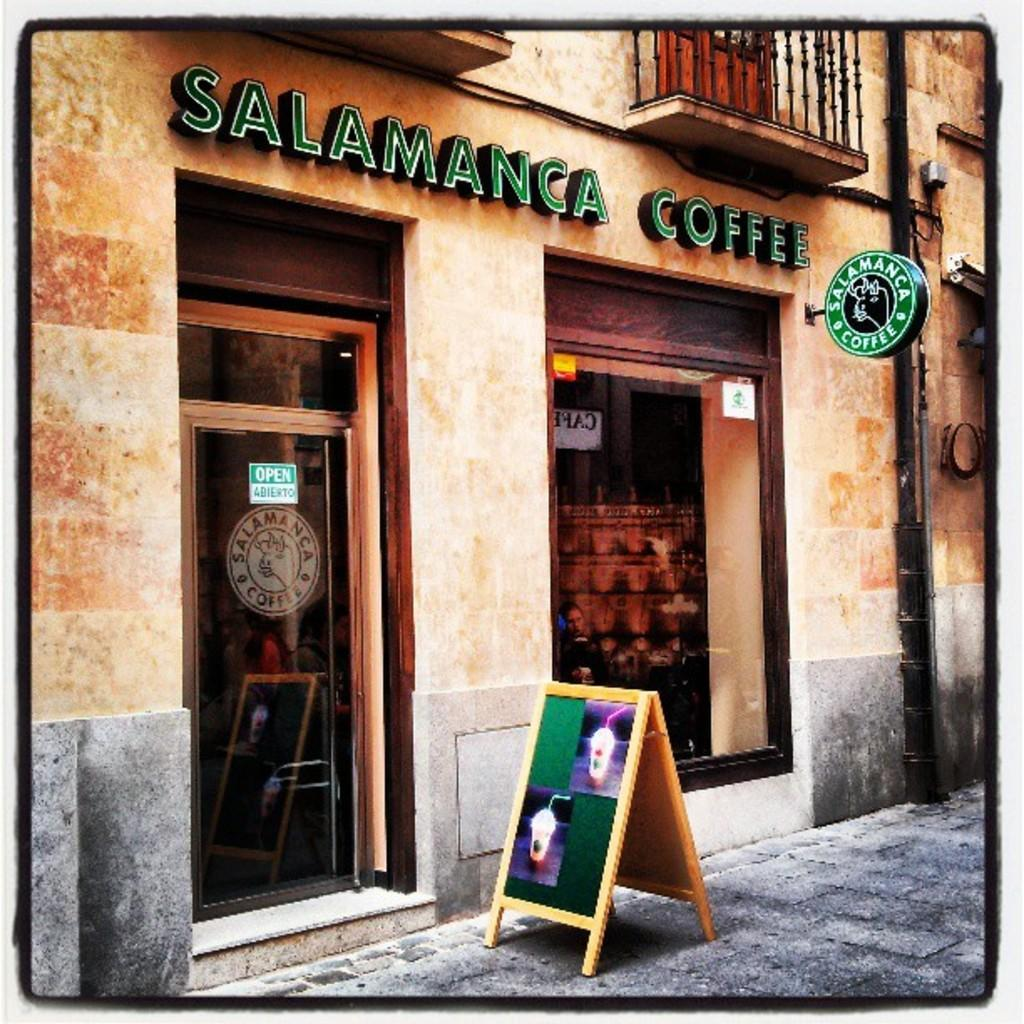<image>
Relay a brief, clear account of the picture shown. A coffee shop exterior is shown called Salamanca Coffee 